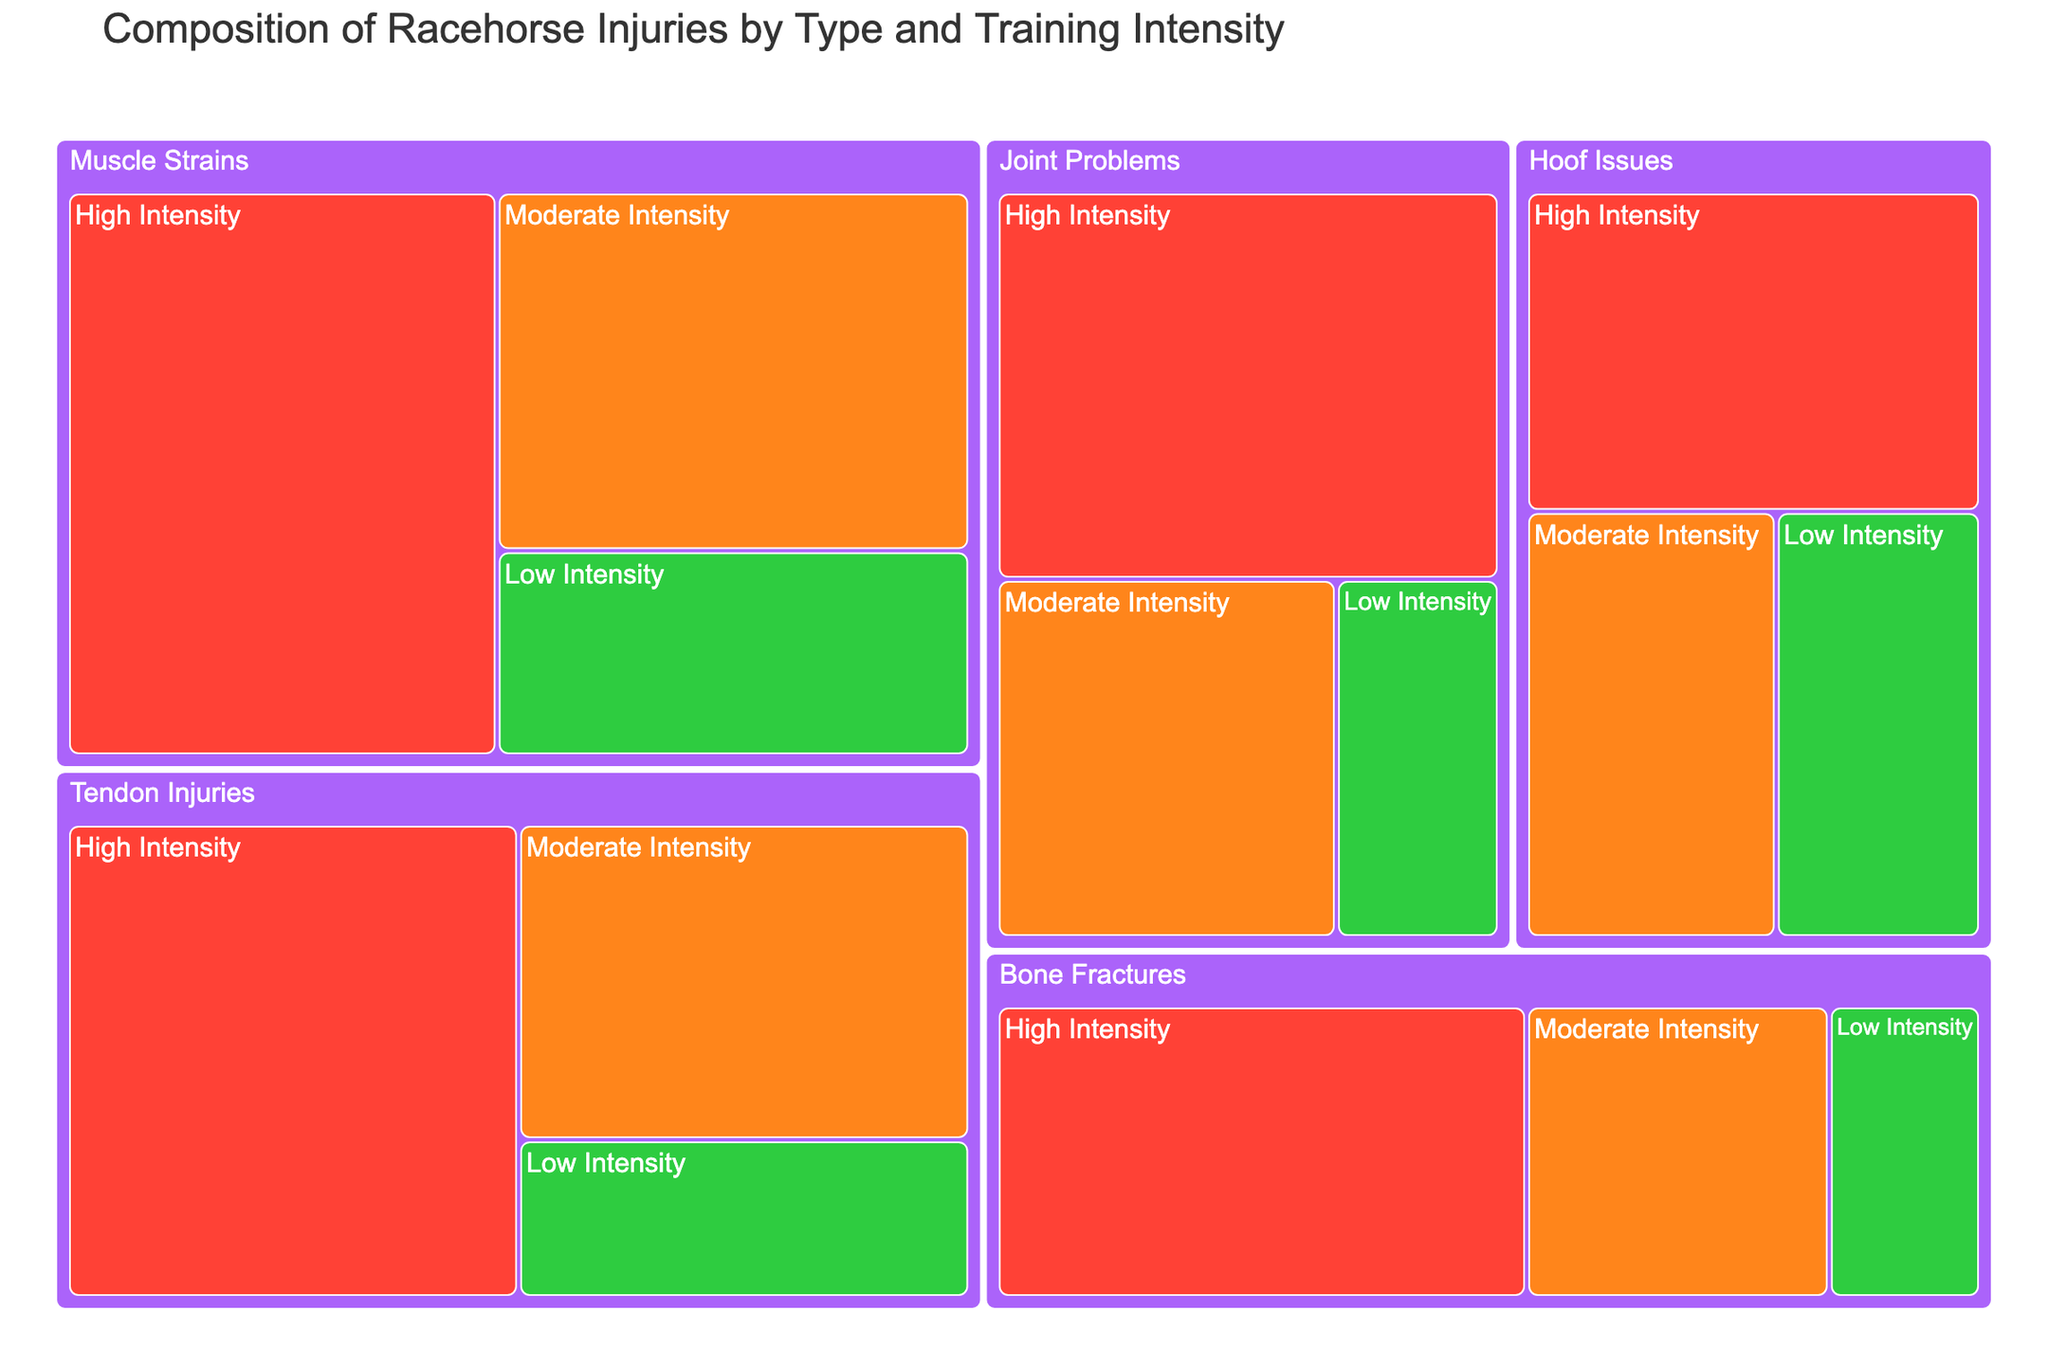What injury type has the highest frequency for high-intensity training? Look at the segments under "High Intensity" and identify the injury type with the largest size. The largest segment is "Muscle Strains" with a frequency of 50.
Answer: Muscle Strains How many total injuries occur under moderate intensity training? Sum the frequencies of all injury types under "Moderate Intensity". The frequencies are: 30 (Tendon Injuries) + 20 (Bone Fractures) + 25 (Joint Problems) + 35 (Muscle Strains) + 22 (Hoof Issues), summing to 132.
Answer: 132 Which injury type appears to be the least frequent under low-intensity training? Compare the sizes of the segments under "Low Intensity". The smallest segment is "Bone Fractures" with a frequency of 10.
Answer: Bone Fractures Are muscle strains more frequent under high intensity or moderate intensity training? Compare the frequencies of "Muscle Strains" under high and moderate intensity. High Intensity has 50 and Moderate Intensity has 35. So, it's more frequent under high intensity.
Answer: High Intensity What's the total frequency of tendon injuries across all training intensities? Sum the frequencies of "Tendon Injuries" across high (45), moderate (30), and low (15) intensities, which total 90.
Answer: 90 What is the most common injury type under low-intensity training? Look at the segments under "Low Intensity" and identify the largest segment. The largest segment is "Muscle Strains" with a frequency of 20.
Answer: Muscle Strains Which training intensity category has the highest total frequency of injuries? Sum the frequencies of all injury types for each intensity category. High: 45+35+40+50+30 = 200, Moderate: 30+20+25+35+22 = 132, Low: 15+10+12+20+18 = 75. High Intensity has the highest total.
Answer: High Intensity How does the frequency of hoof issues under high-intensity training compare to low-intensity training? Compare the frequencies of "Hoof Issues" under high (30) and low (18) intensities. High intensity has a higher frequency.
Answer: High Intensity is higher What is the overall proportion of joint problems compared to muscle strains in high-intensity training? Compute the ratio of the frequency of "Joint Problems" to "Muscle Strains" under high intensity. Joint Problems (40) / Muscle Strains (50) = 0.8. So, joint problems are 80% as frequent as muscle strains.
Answer: 0.8 What proportion of the total injuries does moderate intensity training contribute to tendon injuries? The total frequency of tendon injuries is 90, and moderate intensity contributes 30. So, 30/90 = 0.33 or 33%.
Answer: 33% 